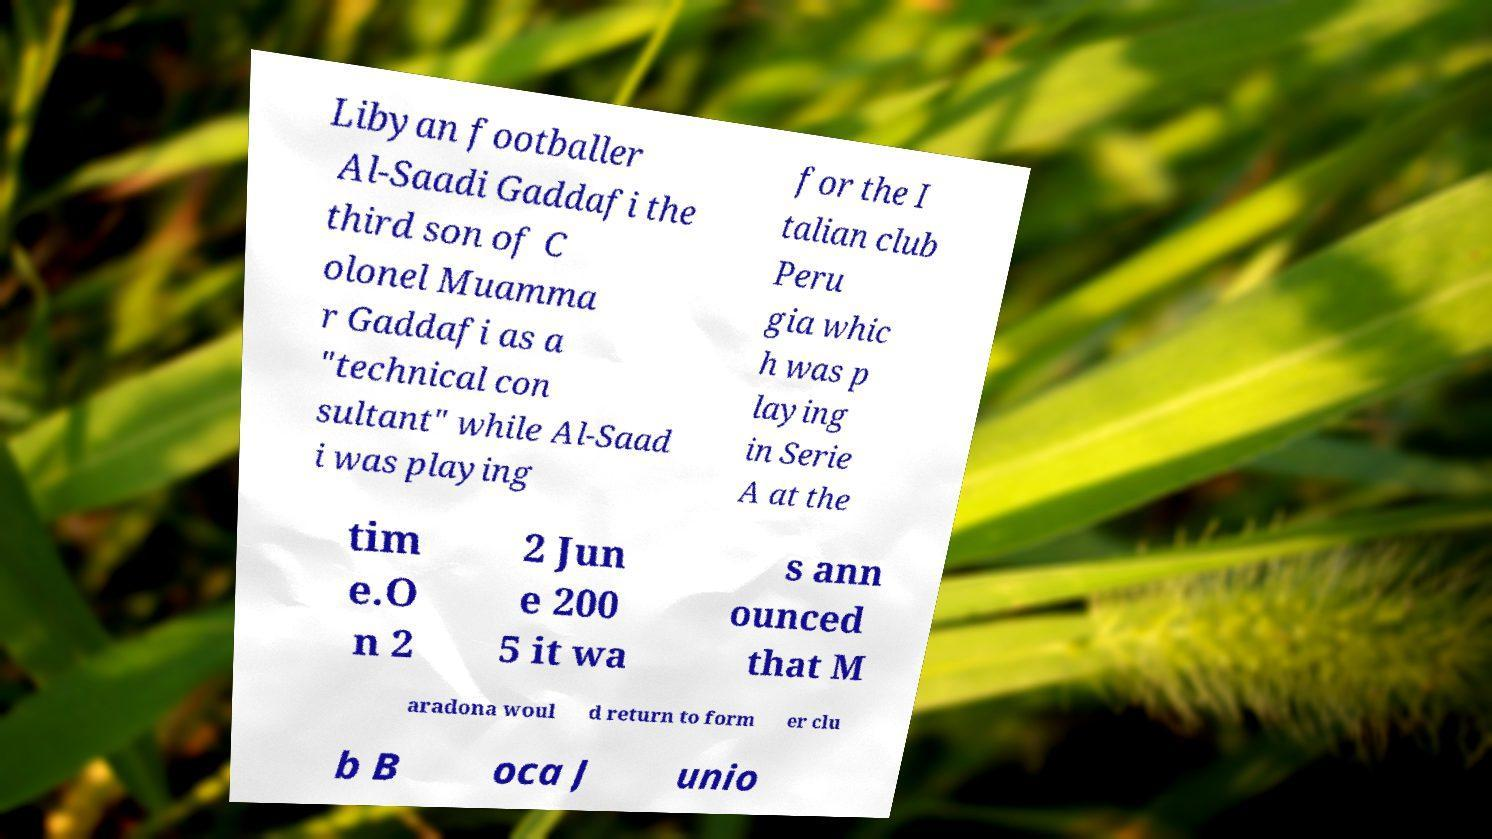Please read and relay the text visible in this image. What does it say? Libyan footballer Al-Saadi Gaddafi the third son of C olonel Muamma r Gaddafi as a "technical con sultant" while Al-Saad i was playing for the I talian club Peru gia whic h was p laying in Serie A at the tim e.O n 2 2 Jun e 200 5 it wa s ann ounced that M aradona woul d return to form er clu b B oca J unio 